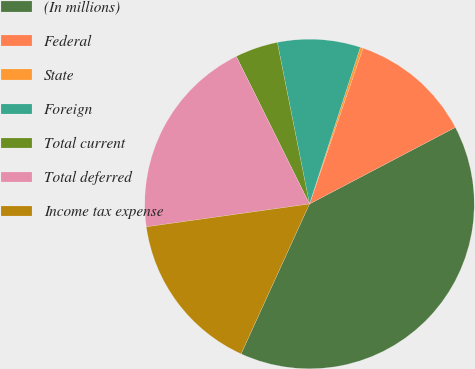Convert chart to OTSL. <chart><loc_0><loc_0><loc_500><loc_500><pie_chart><fcel>(In millions)<fcel>Federal<fcel>State<fcel>Foreign<fcel>Total current<fcel>Total deferred<fcel>Income tax expense<nl><fcel>39.51%<fcel>12.04%<fcel>0.27%<fcel>8.12%<fcel>4.2%<fcel>19.89%<fcel>15.97%<nl></chart> 